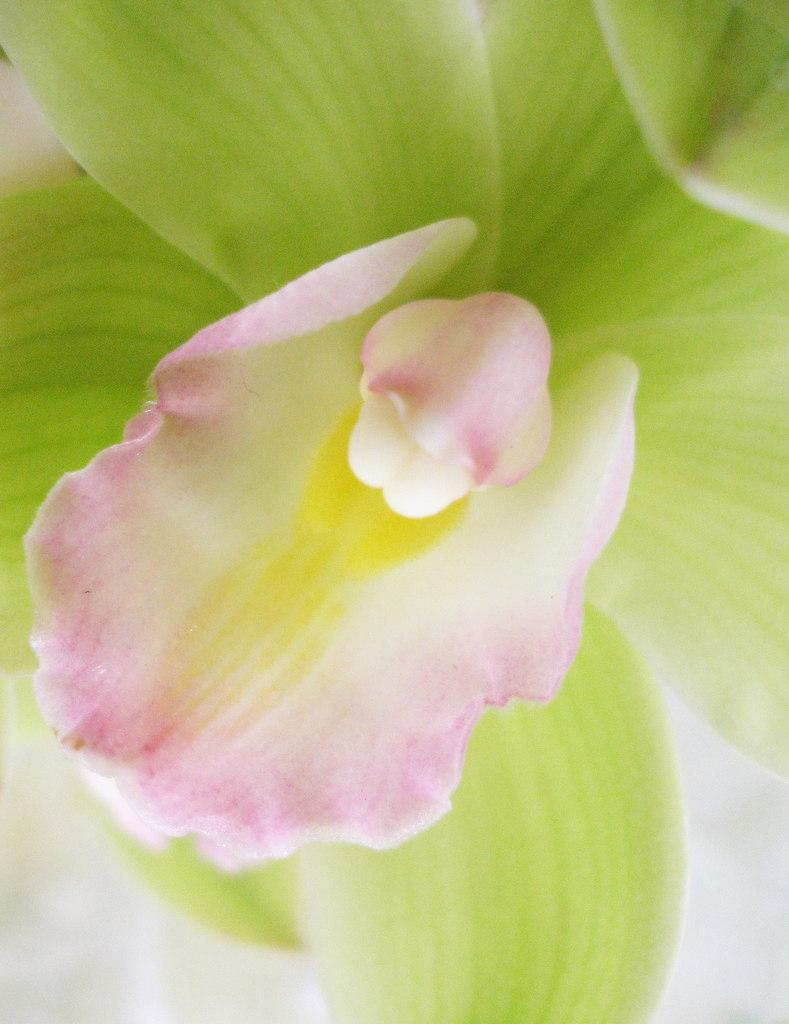What is the main subject of the image? There is a flower in the image. Can you describe the colors of the flower? The flower has pink, white, yellow, and green colors. What is the color of the background in the image? The background of the image is white. How does the cow pull the flower in the image? There is no cow present in the image, and therefore no such action can be observed. 